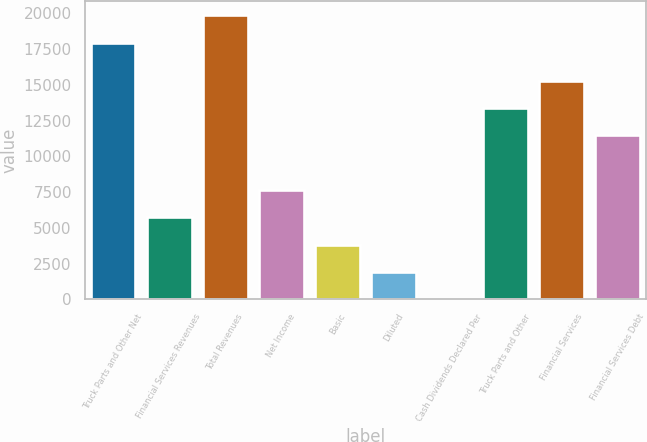<chart> <loc_0><loc_0><loc_500><loc_500><bar_chart><fcel>Truck Parts and Other Net<fcel>Financial Services Revenues<fcel>Total Revenues<fcel>Net Income<fcel>Basic<fcel>Diluted<fcel>Cash Dividends Declared Per<fcel>Truck Parts and Other<fcel>Financial Services<fcel>Financial Services Debt<nl><fcel>17942.8<fcel>5736.16<fcel>19854.1<fcel>7647.44<fcel>3824.88<fcel>1913.6<fcel>2.32<fcel>13381.3<fcel>15292.6<fcel>11470<nl></chart> 